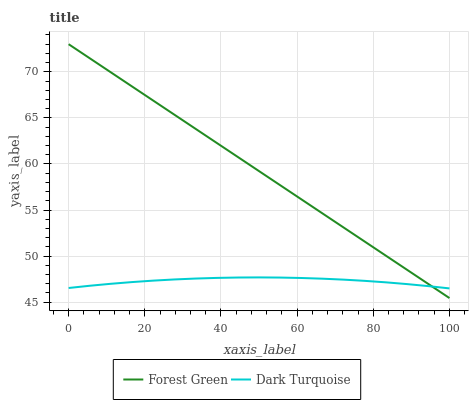Does Dark Turquoise have the minimum area under the curve?
Answer yes or no. Yes. Does Forest Green have the maximum area under the curve?
Answer yes or no. Yes. Does Forest Green have the minimum area under the curve?
Answer yes or no. No. Is Forest Green the smoothest?
Answer yes or no. Yes. Is Dark Turquoise the roughest?
Answer yes or no. Yes. Is Forest Green the roughest?
Answer yes or no. No. Does Forest Green have the highest value?
Answer yes or no. Yes. 